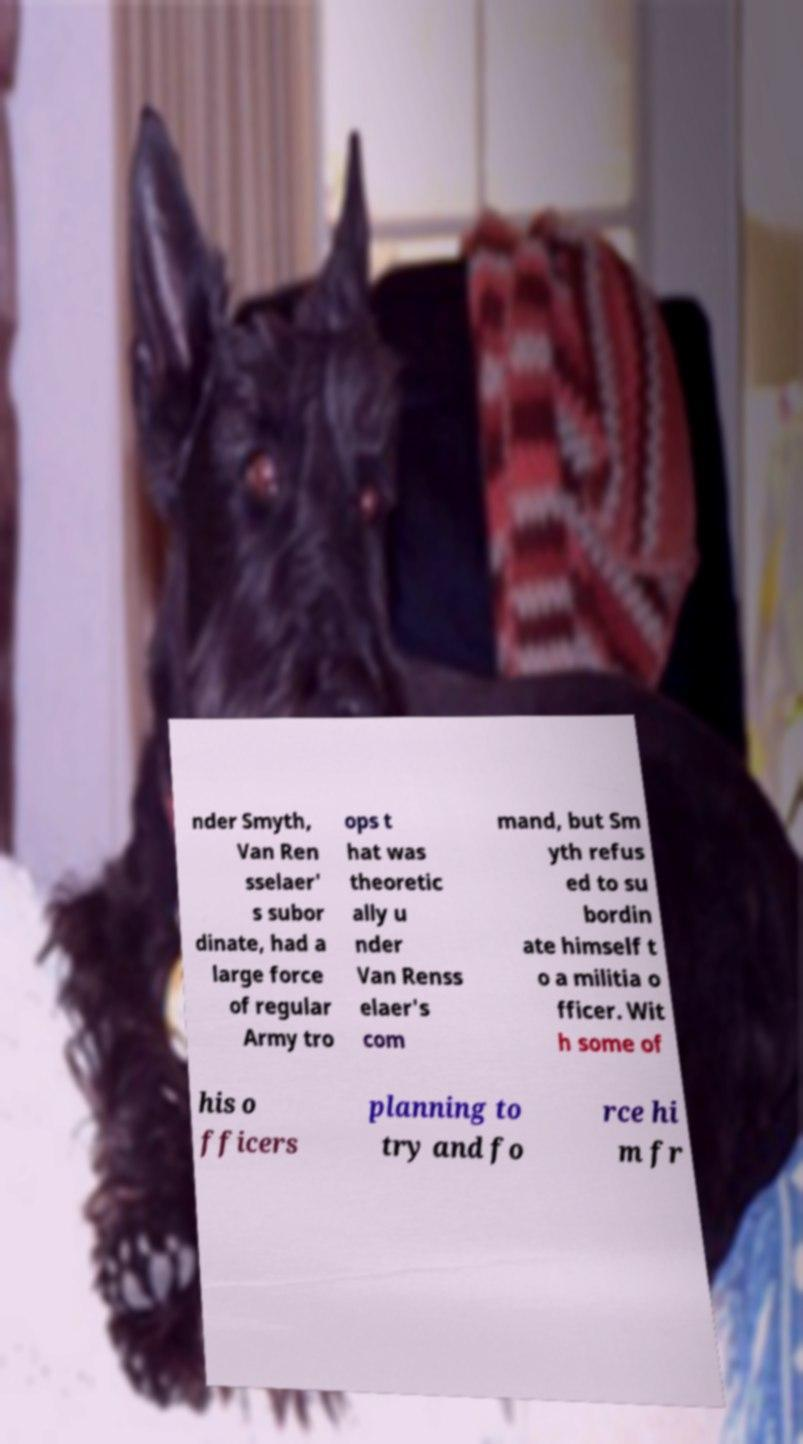Could you assist in decoding the text presented in this image and type it out clearly? nder Smyth, Van Ren sselaer' s subor dinate, had a large force of regular Army tro ops t hat was theoretic ally u nder Van Renss elaer's com mand, but Sm yth refus ed to su bordin ate himself t o a militia o fficer. Wit h some of his o fficers planning to try and fo rce hi m fr 